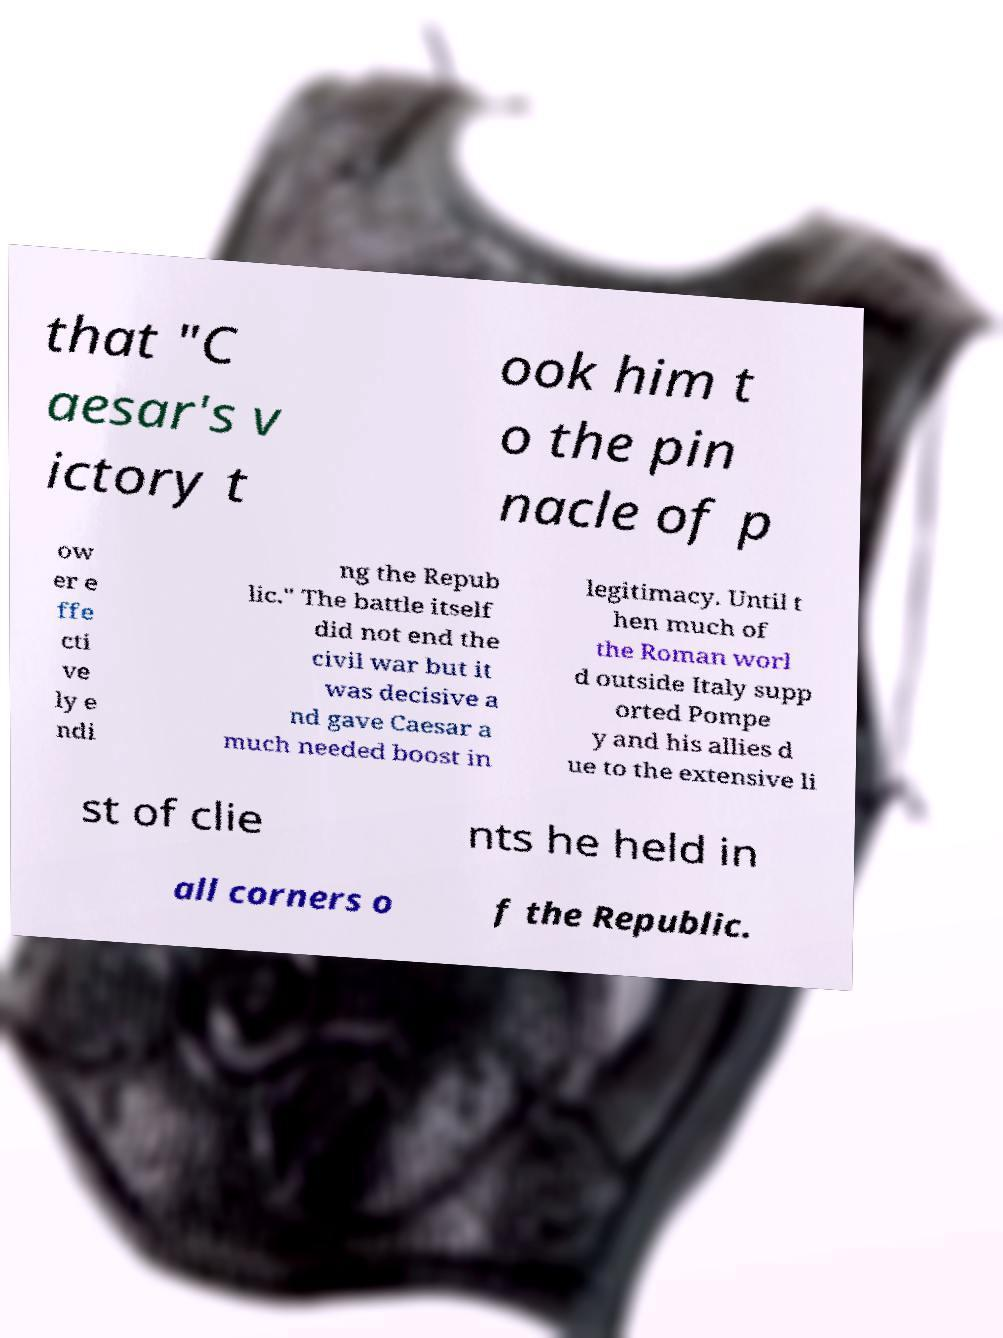Could you assist in decoding the text presented in this image and type it out clearly? that "C aesar's v ictory t ook him t o the pin nacle of p ow er e ffe cti ve ly e ndi ng the Repub lic." The battle itself did not end the civil war but it was decisive a nd gave Caesar a much needed boost in legitimacy. Until t hen much of the Roman worl d outside Italy supp orted Pompe y and his allies d ue to the extensive li st of clie nts he held in all corners o f the Republic. 